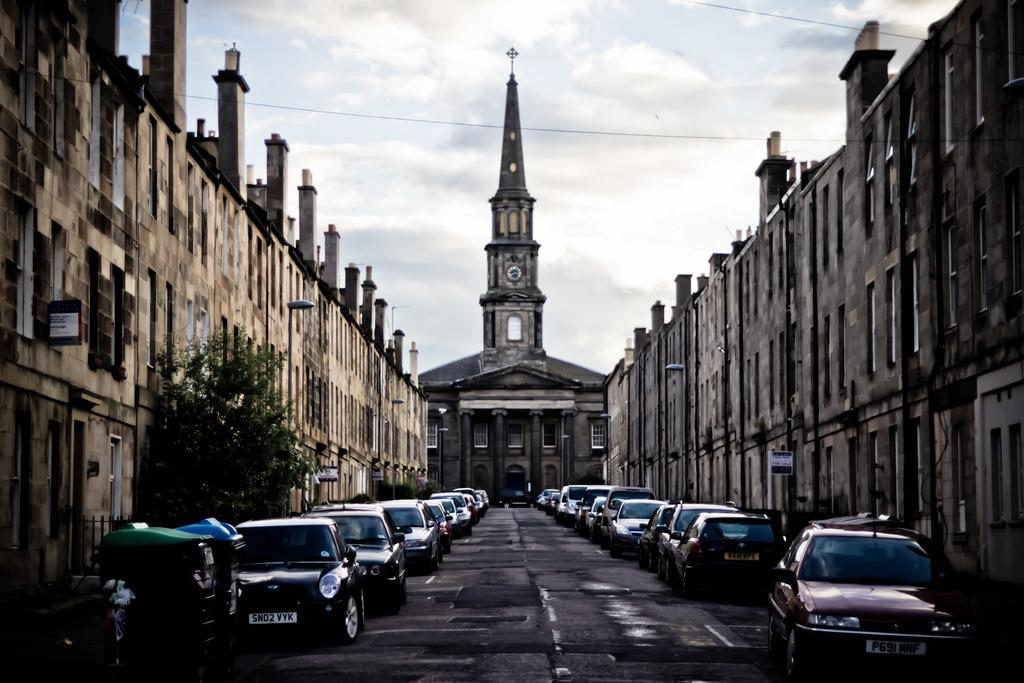What is the main feature of the image? The main feature of the image is a road. What can be seen on the road? There are cars on the road. What surrounds the road? There are buildings on either side of the road. What can be seen in the background of the image? There is a clock tower in the background of the image. What type of business is being conducted in the image? The image does not depict any specific business activity; it primarily shows a road with cars and buildings. 